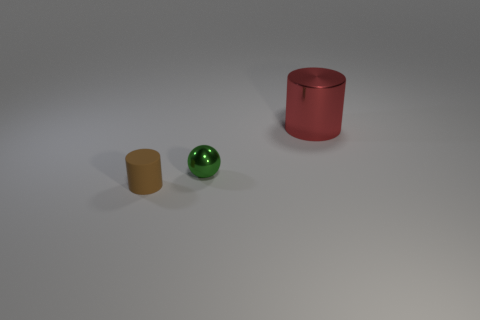Subtract 1 balls. How many balls are left? 0 Add 1 tiny brown things. How many objects exist? 4 Subtract 0 yellow cylinders. How many objects are left? 3 Subtract all balls. How many objects are left? 2 Subtract all red spheres. Subtract all red blocks. How many spheres are left? 1 Subtract all gray cubes. How many red spheres are left? 0 Subtract all big red metallic cylinders. Subtract all tiny green shiny spheres. How many objects are left? 1 Add 3 matte cylinders. How many matte cylinders are left? 4 Add 3 green balls. How many green balls exist? 4 Subtract all brown cylinders. How many cylinders are left? 1 